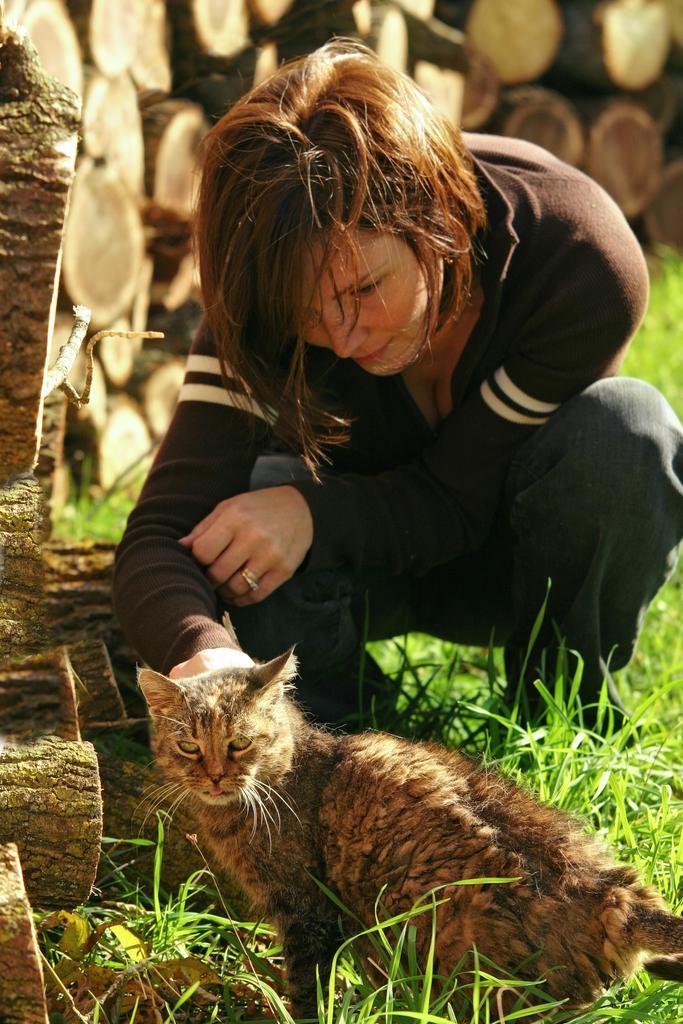Can you describe this image briefly? In this picture there is a woman wearing black colour shirt seeing the cat and background of her there is a bunch of wood kept and theres grass on the floor and women wearing a ring. 